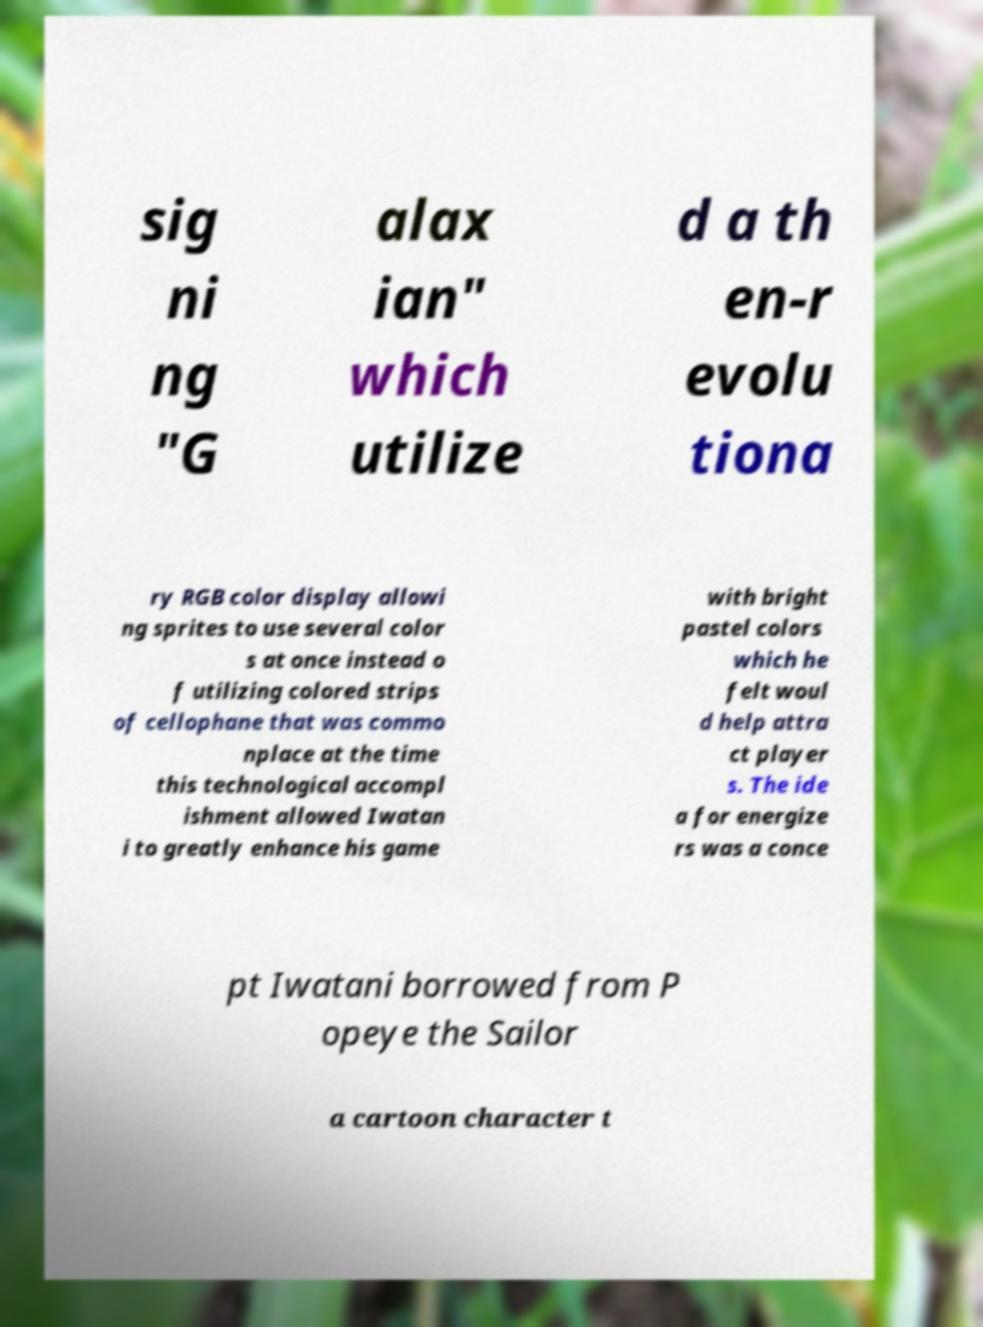What messages or text are displayed in this image? I need them in a readable, typed format. sig ni ng "G alax ian" which utilize d a th en-r evolu tiona ry RGB color display allowi ng sprites to use several color s at once instead o f utilizing colored strips of cellophane that was commo nplace at the time this technological accompl ishment allowed Iwatan i to greatly enhance his game with bright pastel colors which he felt woul d help attra ct player s. The ide a for energize rs was a conce pt Iwatani borrowed from P opeye the Sailor a cartoon character t 